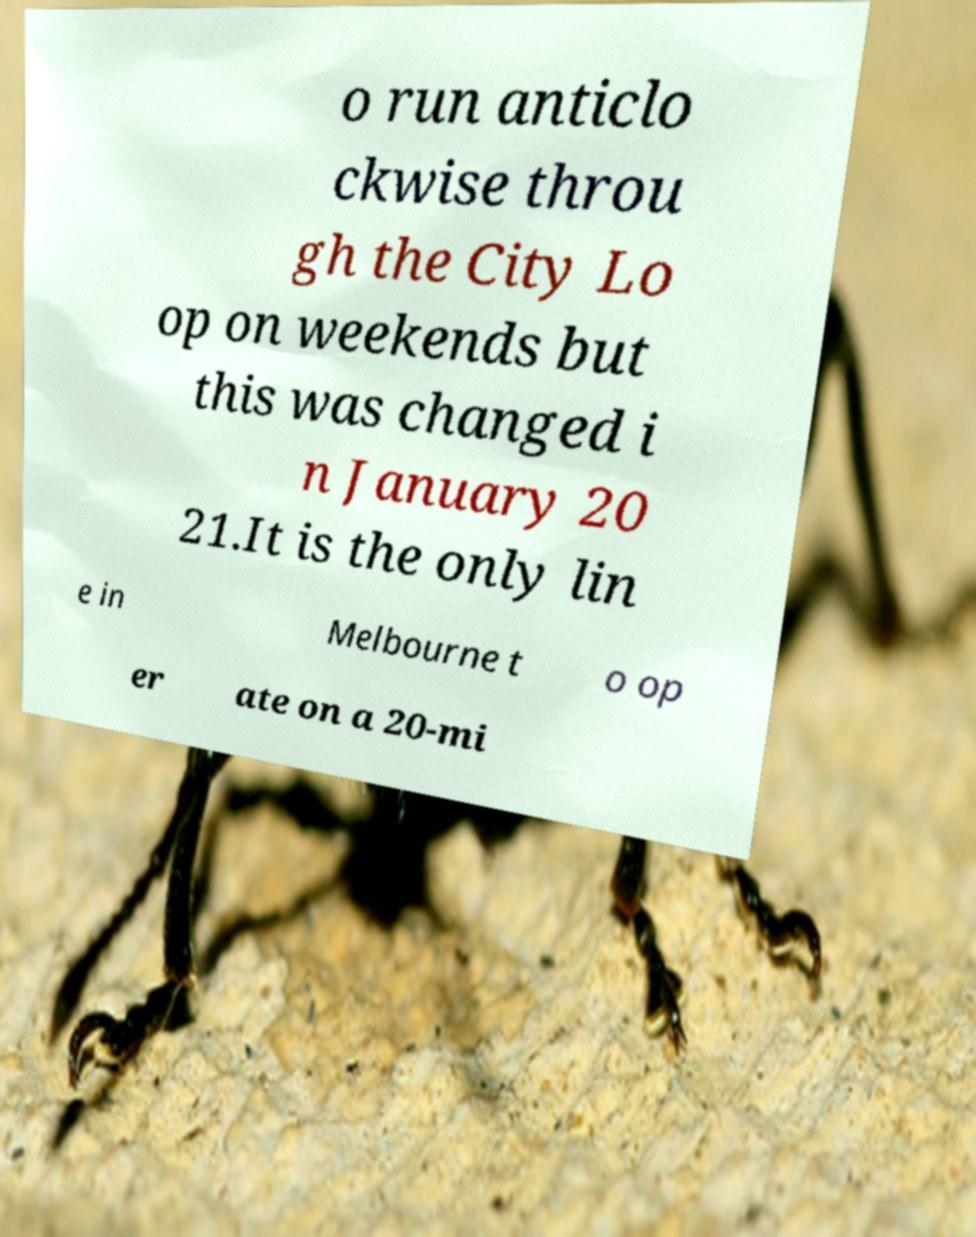I need the written content from this picture converted into text. Can you do that? o run anticlo ckwise throu gh the City Lo op on weekends but this was changed i n January 20 21.It is the only lin e in Melbourne t o op er ate on a 20-mi 